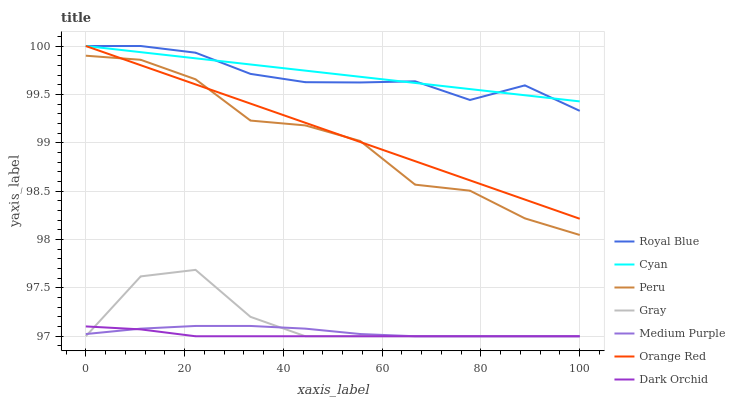Does Dark Orchid have the minimum area under the curve?
Answer yes or no. Yes. Does Cyan have the maximum area under the curve?
Answer yes or no. Yes. Does Medium Purple have the minimum area under the curve?
Answer yes or no. No. Does Medium Purple have the maximum area under the curve?
Answer yes or no. No. Is Orange Red the smoothest?
Answer yes or no. Yes. Is Peru the roughest?
Answer yes or no. Yes. Is Dark Orchid the smoothest?
Answer yes or no. No. Is Dark Orchid the roughest?
Answer yes or no. No. Does Gray have the lowest value?
Answer yes or no. Yes. Does Royal Blue have the lowest value?
Answer yes or no. No. Does Orange Red have the highest value?
Answer yes or no. Yes. Does Medium Purple have the highest value?
Answer yes or no. No. Is Medium Purple less than Royal Blue?
Answer yes or no. Yes. Is Royal Blue greater than Peru?
Answer yes or no. Yes. Does Orange Red intersect Peru?
Answer yes or no. Yes. Is Orange Red less than Peru?
Answer yes or no. No. Is Orange Red greater than Peru?
Answer yes or no. No. Does Medium Purple intersect Royal Blue?
Answer yes or no. No. 